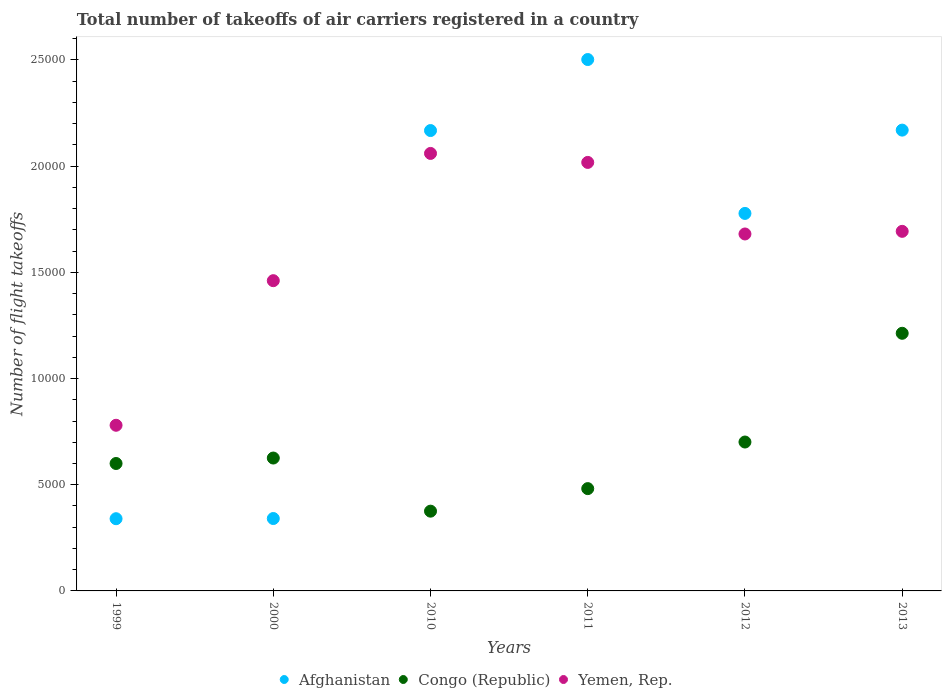How many different coloured dotlines are there?
Your response must be concise. 3. Is the number of dotlines equal to the number of legend labels?
Your answer should be very brief. Yes. What is the total number of flight takeoffs in Congo (Republic) in 2012?
Keep it short and to the point. 7011. Across all years, what is the maximum total number of flight takeoffs in Afghanistan?
Ensure brevity in your answer.  2.50e+04. Across all years, what is the minimum total number of flight takeoffs in Yemen, Rep.?
Ensure brevity in your answer.  7800. What is the total total number of flight takeoffs in Yemen, Rep. in the graph?
Provide a succinct answer. 9.69e+04. What is the difference between the total number of flight takeoffs in Afghanistan in 2012 and the total number of flight takeoffs in Congo (Republic) in 2010?
Offer a very short reply. 1.40e+04. What is the average total number of flight takeoffs in Congo (Republic) per year?
Provide a short and direct response. 6661.84. In the year 2000, what is the difference between the total number of flight takeoffs in Congo (Republic) and total number of flight takeoffs in Yemen, Rep.?
Provide a short and direct response. -8351. What is the ratio of the total number of flight takeoffs in Yemen, Rep. in 2010 to that in 2013?
Provide a short and direct response. 1.22. Is the total number of flight takeoffs in Yemen, Rep. in 1999 less than that in 2010?
Your response must be concise. Yes. Is the difference between the total number of flight takeoffs in Congo (Republic) in 2010 and 2011 greater than the difference between the total number of flight takeoffs in Yemen, Rep. in 2010 and 2011?
Your answer should be very brief. No. What is the difference between the highest and the second highest total number of flight takeoffs in Afghanistan?
Give a very brief answer. 3323.69. What is the difference between the highest and the lowest total number of flight takeoffs in Congo (Republic)?
Your response must be concise. 8375.4. In how many years, is the total number of flight takeoffs in Yemen, Rep. greater than the average total number of flight takeoffs in Yemen, Rep. taken over all years?
Make the answer very short. 4. Is the sum of the total number of flight takeoffs in Congo (Republic) in 2000 and 2011 greater than the maximum total number of flight takeoffs in Yemen, Rep. across all years?
Offer a very short reply. No. How many years are there in the graph?
Your answer should be very brief. 6. Are the values on the major ticks of Y-axis written in scientific E-notation?
Keep it short and to the point. No. Does the graph contain any zero values?
Give a very brief answer. No. Does the graph contain grids?
Ensure brevity in your answer.  No. Where does the legend appear in the graph?
Offer a terse response. Bottom center. How are the legend labels stacked?
Keep it short and to the point. Horizontal. What is the title of the graph?
Your answer should be compact. Total number of takeoffs of air carriers registered in a country. What is the label or title of the X-axis?
Give a very brief answer. Years. What is the label or title of the Y-axis?
Your response must be concise. Number of flight takeoffs. What is the Number of flight takeoffs in Afghanistan in 1999?
Offer a very short reply. 3400. What is the Number of flight takeoffs of Congo (Republic) in 1999?
Keep it short and to the point. 6000. What is the Number of flight takeoffs of Yemen, Rep. in 1999?
Make the answer very short. 7800. What is the Number of flight takeoffs in Afghanistan in 2000?
Ensure brevity in your answer.  3409. What is the Number of flight takeoffs in Congo (Republic) in 2000?
Offer a terse response. 6257. What is the Number of flight takeoffs in Yemen, Rep. in 2000?
Ensure brevity in your answer.  1.46e+04. What is the Number of flight takeoffs of Afghanistan in 2010?
Your answer should be compact. 2.17e+04. What is the Number of flight takeoffs of Congo (Republic) in 2010?
Offer a terse response. 3755.33. What is the Number of flight takeoffs in Yemen, Rep. in 2010?
Keep it short and to the point. 2.06e+04. What is the Number of flight takeoffs of Afghanistan in 2011?
Ensure brevity in your answer.  2.50e+04. What is the Number of flight takeoffs in Congo (Republic) in 2011?
Your answer should be very brief. 4817. What is the Number of flight takeoffs in Yemen, Rep. in 2011?
Your answer should be compact. 2.02e+04. What is the Number of flight takeoffs in Afghanistan in 2012?
Ensure brevity in your answer.  1.78e+04. What is the Number of flight takeoffs in Congo (Republic) in 2012?
Provide a succinct answer. 7011. What is the Number of flight takeoffs in Yemen, Rep. in 2012?
Provide a succinct answer. 1.68e+04. What is the Number of flight takeoffs of Afghanistan in 2013?
Your answer should be compact. 2.17e+04. What is the Number of flight takeoffs in Congo (Republic) in 2013?
Offer a very short reply. 1.21e+04. What is the Number of flight takeoffs of Yemen, Rep. in 2013?
Provide a short and direct response. 1.69e+04. Across all years, what is the maximum Number of flight takeoffs in Afghanistan?
Offer a terse response. 2.50e+04. Across all years, what is the maximum Number of flight takeoffs of Congo (Republic)?
Provide a short and direct response. 1.21e+04. Across all years, what is the maximum Number of flight takeoffs of Yemen, Rep.?
Keep it short and to the point. 2.06e+04. Across all years, what is the minimum Number of flight takeoffs of Afghanistan?
Your answer should be very brief. 3400. Across all years, what is the minimum Number of flight takeoffs in Congo (Republic)?
Your answer should be compact. 3755.33. Across all years, what is the minimum Number of flight takeoffs in Yemen, Rep.?
Your answer should be very brief. 7800. What is the total Number of flight takeoffs of Afghanistan in the graph?
Your response must be concise. 9.30e+04. What is the total Number of flight takeoffs of Congo (Republic) in the graph?
Make the answer very short. 4.00e+04. What is the total Number of flight takeoffs in Yemen, Rep. in the graph?
Ensure brevity in your answer.  9.69e+04. What is the difference between the Number of flight takeoffs in Congo (Republic) in 1999 and that in 2000?
Offer a terse response. -257. What is the difference between the Number of flight takeoffs of Yemen, Rep. in 1999 and that in 2000?
Ensure brevity in your answer.  -6808. What is the difference between the Number of flight takeoffs of Afghanistan in 1999 and that in 2010?
Give a very brief answer. -1.83e+04. What is the difference between the Number of flight takeoffs in Congo (Republic) in 1999 and that in 2010?
Provide a short and direct response. 2244.67. What is the difference between the Number of flight takeoffs of Yemen, Rep. in 1999 and that in 2010?
Keep it short and to the point. -1.28e+04. What is the difference between the Number of flight takeoffs in Afghanistan in 1999 and that in 2011?
Provide a succinct answer. -2.16e+04. What is the difference between the Number of flight takeoffs of Congo (Republic) in 1999 and that in 2011?
Offer a very short reply. 1183. What is the difference between the Number of flight takeoffs of Yemen, Rep. in 1999 and that in 2011?
Offer a terse response. -1.24e+04. What is the difference between the Number of flight takeoffs in Afghanistan in 1999 and that in 2012?
Offer a very short reply. -1.44e+04. What is the difference between the Number of flight takeoffs of Congo (Republic) in 1999 and that in 2012?
Provide a short and direct response. -1011. What is the difference between the Number of flight takeoffs in Yemen, Rep. in 1999 and that in 2012?
Offer a very short reply. -9007.41. What is the difference between the Number of flight takeoffs of Afghanistan in 1999 and that in 2013?
Ensure brevity in your answer.  -1.83e+04. What is the difference between the Number of flight takeoffs of Congo (Republic) in 1999 and that in 2013?
Offer a very short reply. -6130.73. What is the difference between the Number of flight takeoffs in Yemen, Rep. in 1999 and that in 2013?
Provide a short and direct response. -9131.24. What is the difference between the Number of flight takeoffs of Afghanistan in 2000 and that in 2010?
Keep it short and to the point. -1.83e+04. What is the difference between the Number of flight takeoffs in Congo (Republic) in 2000 and that in 2010?
Provide a short and direct response. 2501.67. What is the difference between the Number of flight takeoffs of Yemen, Rep. in 2000 and that in 2010?
Your answer should be compact. -5992. What is the difference between the Number of flight takeoffs in Afghanistan in 2000 and that in 2011?
Offer a terse response. -2.16e+04. What is the difference between the Number of flight takeoffs of Congo (Republic) in 2000 and that in 2011?
Provide a succinct answer. 1440. What is the difference between the Number of flight takeoffs of Yemen, Rep. in 2000 and that in 2011?
Keep it short and to the point. -5568.73. What is the difference between the Number of flight takeoffs in Afghanistan in 2000 and that in 2012?
Your answer should be very brief. -1.44e+04. What is the difference between the Number of flight takeoffs of Congo (Republic) in 2000 and that in 2012?
Your response must be concise. -754. What is the difference between the Number of flight takeoffs in Yemen, Rep. in 2000 and that in 2012?
Your answer should be very brief. -2199.41. What is the difference between the Number of flight takeoffs of Afghanistan in 2000 and that in 2013?
Provide a succinct answer. -1.83e+04. What is the difference between the Number of flight takeoffs of Congo (Republic) in 2000 and that in 2013?
Your answer should be compact. -5873.73. What is the difference between the Number of flight takeoffs in Yemen, Rep. in 2000 and that in 2013?
Give a very brief answer. -2323.24. What is the difference between the Number of flight takeoffs of Afghanistan in 2010 and that in 2011?
Give a very brief answer. -3344. What is the difference between the Number of flight takeoffs in Congo (Republic) in 2010 and that in 2011?
Offer a terse response. -1061.67. What is the difference between the Number of flight takeoffs in Yemen, Rep. in 2010 and that in 2011?
Offer a terse response. 423.27. What is the difference between the Number of flight takeoffs of Afghanistan in 2010 and that in 2012?
Your answer should be very brief. 3902. What is the difference between the Number of flight takeoffs in Congo (Republic) in 2010 and that in 2012?
Provide a short and direct response. -3255.67. What is the difference between the Number of flight takeoffs in Yemen, Rep. in 2010 and that in 2012?
Give a very brief answer. 3792.59. What is the difference between the Number of flight takeoffs in Afghanistan in 2010 and that in 2013?
Provide a short and direct response. -20.31. What is the difference between the Number of flight takeoffs in Congo (Republic) in 2010 and that in 2013?
Offer a terse response. -8375.4. What is the difference between the Number of flight takeoffs of Yemen, Rep. in 2010 and that in 2013?
Give a very brief answer. 3668.76. What is the difference between the Number of flight takeoffs in Afghanistan in 2011 and that in 2012?
Your answer should be very brief. 7246. What is the difference between the Number of flight takeoffs in Congo (Republic) in 2011 and that in 2012?
Your answer should be compact. -2194. What is the difference between the Number of flight takeoffs in Yemen, Rep. in 2011 and that in 2012?
Ensure brevity in your answer.  3369.32. What is the difference between the Number of flight takeoffs of Afghanistan in 2011 and that in 2013?
Make the answer very short. 3323.69. What is the difference between the Number of flight takeoffs in Congo (Republic) in 2011 and that in 2013?
Offer a terse response. -7313.73. What is the difference between the Number of flight takeoffs in Yemen, Rep. in 2011 and that in 2013?
Provide a short and direct response. 3245.49. What is the difference between the Number of flight takeoffs of Afghanistan in 2012 and that in 2013?
Your answer should be compact. -3922.31. What is the difference between the Number of flight takeoffs of Congo (Republic) in 2012 and that in 2013?
Provide a succinct answer. -5119.73. What is the difference between the Number of flight takeoffs in Yemen, Rep. in 2012 and that in 2013?
Provide a succinct answer. -123.83. What is the difference between the Number of flight takeoffs of Afghanistan in 1999 and the Number of flight takeoffs of Congo (Republic) in 2000?
Provide a short and direct response. -2857. What is the difference between the Number of flight takeoffs in Afghanistan in 1999 and the Number of flight takeoffs in Yemen, Rep. in 2000?
Make the answer very short. -1.12e+04. What is the difference between the Number of flight takeoffs of Congo (Republic) in 1999 and the Number of flight takeoffs of Yemen, Rep. in 2000?
Your response must be concise. -8608. What is the difference between the Number of flight takeoffs in Afghanistan in 1999 and the Number of flight takeoffs in Congo (Republic) in 2010?
Offer a very short reply. -355.33. What is the difference between the Number of flight takeoffs of Afghanistan in 1999 and the Number of flight takeoffs of Yemen, Rep. in 2010?
Offer a terse response. -1.72e+04. What is the difference between the Number of flight takeoffs of Congo (Republic) in 1999 and the Number of flight takeoffs of Yemen, Rep. in 2010?
Give a very brief answer. -1.46e+04. What is the difference between the Number of flight takeoffs of Afghanistan in 1999 and the Number of flight takeoffs of Congo (Republic) in 2011?
Make the answer very short. -1417. What is the difference between the Number of flight takeoffs of Afghanistan in 1999 and the Number of flight takeoffs of Yemen, Rep. in 2011?
Your answer should be compact. -1.68e+04. What is the difference between the Number of flight takeoffs of Congo (Republic) in 1999 and the Number of flight takeoffs of Yemen, Rep. in 2011?
Provide a succinct answer. -1.42e+04. What is the difference between the Number of flight takeoffs in Afghanistan in 1999 and the Number of flight takeoffs in Congo (Republic) in 2012?
Your answer should be compact. -3611. What is the difference between the Number of flight takeoffs in Afghanistan in 1999 and the Number of flight takeoffs in Yemen, Rep. in 2012?
Your answer should be very brief. -1.34e+04. What is the difference between the Number of flight takeoffs in Congo (Republic) in 1999 and the Number of flight takeoffs in Yemen, Rep. in 2012?
Your answer should be compact. -1.08e+04. What is the difference between the Number of flight takeoffs of Afghanistan in 1999 and the Number of flight takeoffs of Congo (Republic) in 2013?
Provide a succinct answer. -8730.73. What is the difference between the Number of flight takeoffs in Afghanistan in 1999 and the Number of flight takeoffs in Yemen, Rep. in 2013?
Your answer should be compact. -1.35e+04. What is the difference between the Number of flight takeoffs of Congo (Republic) in 1999 and the Number of flight takeoffs of Yemen, Rep. in 2013?
Keep it short and to the point. -1.09e+04. What is the difference between the Number of flight takeoffs of Afghanistan in 2000 and the Number of flight takeoffs of Congo (Republic) in 2010?
Keep it short and to the point. -346.33. What is the difference between the Number of flight takeoffs in Afghanistan in 2000 and the Number of flight takeoffs in Yemen, Rep. in 2010?
Make the answer very short. -1.72e+04. What is the difference between the Number of flight takeoffs in Congo (Republic) in 2000 and the Number of flight takeoffs in Yemen, Rep. in 2010?
Your answer should be compact. -1.43e+04. What is the difference between the Number of flight takeoffs of Afghanistan in 2000 and the Number of flight takeoffs of Congo (Republic) in 2011?
Offer a very short reply. -1408. What is the difference between the Number of flight takeoffs of Afghanistan in 2000 and the Number of flight takeoffs of Yemen, Rep. in 2011?
Your response must be concise. -1.68e+04. What is the difference between the Number of flight takeoffs in Congo (Republic) in 2000 and the Number of flight takeoffs in Yemen, Rep. in 2011?
Ensure brevity in your answer.  -1.39e+04. What is the difference between the Number of flight takeoffs in Afghanistan in 2000 and the Number of flight takeoffs in Congo (Republic) in 2012?
Your response must be concise. -3602. What is the difference between the Number of flight takeoffs of Afghanistan in 2000 and the Number of flight takeoffs of Yemen, Rep. in 2012?
Make the answer very short. -1.34e+04. What is the difference between the Number of flight takeoffs of Congo (Republic) in 2000 and the Number of flight takeoffs of Yemen, Rep. in 2012?
Your answer should be very brief. -1.06e+04. What is the difference between the Number of flight takeoffs of Afghanistan in 2000 and the Number of flight takeoffs of Congo (Republic) in 2013?
Provide a succinct answer. -8721.73. What is the difference between the Number of flight takeoffs in Afghanistan in 2000 and the Number of flight takeoffs in Yemen, Rep. in 2013?
Offer a terse response. -1.35e+04. What is the difference between the Number of flight takeoffs in Congo (Republic) in 2000 and the Number of flight takeoffs in Yemen, Rep. in 2013?
Provide a short and direct response. -1.07e+04. What is the difference between the Number of flight takeoffs of Afghanistan in 2010 and the Number of flight takeoffs of Congo (Republic) in 2011?
Your response must be concise. 1.69e+04. What is the difference between the Number of flight takeoffs in Afghanistan in 2010 and the Number of flight takeoffs in Yemen, Rep. in 2011?
Ensure brevity in your answer.  1500.27. What is the difference between the Number of flight takeoffs in Congo (Republic) in 2010 and the Number of flight takeoffs in Yemen, Rep. in 2011?
Your response must be concise. -1.64e+04. What is the difference between the Number of flight takeoffs of Afghanistan in 2010 and the Number of flight takeoffs of Congo (Republic) in 2012?
Provide a short and direct response. 1.47e+04. What is the difference between the Number of flight takeoffs of Afghanistan in 2010 and the Number of flight takeoffs of Yemen, Rep. in 2012?
Keep it short and to the point. 4869.59. What is the difference between the Number of flight takeoffs of Congo (Republic) in 2010 and the Number of flight takeoffs of Yemen, Rep. in 2012?
Your answer should be very brief. -1.31e+04. What is the difference between the Number of flight takeoffs in Afghanistan in 2010 and the Number of flight takeoffs in Congo (Republic) in 2013?
Make the answer very short. 9546.27. What is the difference between the Number of flight takeoffs of Afghanistan in 2010 and the Number of flight takeoffs of Yemen, Rep. in 2013?
Your answer should be very brief. 4745.76. What is the difference between the Number of flight takeoffs of Congo (Republic) in 2010 and the Number of flight takeoffs of Yemen, Rep. in 2013?
Provide a short and direct response. -1.32e+04. What is the difference between the Number of flight takeoffs of Afghanistan in 2011 and the Number of flight takeoffs of Congo (Republic) in 2012?
Give a very brief answer. 1.80e+04. What is the difference between the Number of flight takeoffs of Afghanistan in 2011 and the Number of flight takeoffs of Yemen, Rep. in 2012?
Offer a very short reply. 8213.59. What is the difference between the Number of flight takeoffs of Congo (Republic) in 2011 and the Number of flight takeoffs of Yemen, Rep. in 2012?
Your answer should be compact. -1.20e+04. What is the difference between the Number of flight takeoffs in Afghanistan in 2011 and the Number of flight takeoffs in Congo (Republic) in 2013?
Your response must be concise. 1.29e+04. What is the difference between the Number of flight takeoffs in Afghanistan in 2011 and the Number of flight takeoffs in Yemen, Rep. in 2013?
Your answer should be compact. 8089.76. What is the difference between the Number of flight takeoffs in Congo (Republic) in 2011 and the Number of flight takeoffs in Yemen, Rep. in 2013?
Provide a succinct answer. -1.21e+04. What is the difference between the Number of flight takeoffs of Afghanistan in 2012 and the Number of flight takeoffs of Congo (Republic) in 2013?
Your answer should be compact. 5644.27. What is the difference between the Number of flight takeoffs of Afghanistan in 2012 and the Number of flight takeoffs of Yemen, Rep. in 2013?
Make the answer very short. 843.76. What is the difference between the Number of flight takeoffs of Congo (Republic) in 2012 and the Number of flight takeoffs of Yemen, Rep. in 2013?
Your response must be concise. -9920.24. What is the average Number of flight takeoffs of Afghanistan per year?
Your response must be concise. 1.55e+04. What is the average Number of flight takeoffs in Congo (Republic) per year?
Offer a terse response. 6661.84. What is the average Number of flight takeoffs of Yemen, Rep. per year?
Offer a terse response. 1.62e+04. In the year 1999, what is the difference between the Number of flight takeoffs in Afghanistan and Number of flight takeoffs in Congo (Republic)?
Keep it short and to the point. -2600. In the year 1999, what is the difference between the Number of flight takeoffs of Afghanistan and Number of flight takeoffs of Yemen, Rep.?
Your answer should be compact. -4400. In the year 1999, what is the difference between the Number of flight takeoffs of Congo (Republic) and Number of flight takeoffs of Yemen, Rep.?
Offer a very short reply. -1800. In the year 2000, what is the difference between the Number of flight takeoffs in Afghanistan and Number of flight takeoffs in Congo (Republic)?
Your answer should be compact. -2848. In the year 2000, what is the difference between the Number of flight takeoffs in Afghanistan and Number of flight takeoffs in Yemen, Rep.?
Your response must be concise. -1.12e+04. In the year 2000, what is the difference between the Number of flight takeoffs of Congo (Republic) and Number of flight takeoffs of Yemen, Rep.?
Your answer should be compact. -8351. In the year 2010, what is the difference between the Number of flight takeoffs in Afghanistan and Number of flight takeoffs in Congo (Republic)?
Give a very brief answer. 1.79e+04. In the year 2010, what is the difference between the Number of flight takeoffs of Afghanistan and Number of flight takeoffs of Yemen, Rep.?
Provide a succinct answer. 1077. In the year 2010, what is the difference between the Number of flight takeoffs of Congo (Republic) and Number of flight takeoffs of Yemen, Rep.?
Your answer should be very brief. -1.68e+04. In the year 2011, what is the difference between the Number of flight takeoffs in Afghanistan and Number of flight takeoffs in Congo (Republic)?
Provide a short and direct response. 2.02e+04. In the year 2011, what is the difference between the Number of flight takeoffs in Afghanistan and Number of flight takeoffs in Yemen, Rep.?
Your answer should be very brief. 4844.27. In the year 2011, what is the difference between the Number of flight takeoffs in Congo (Republic) and Number of flight takeoffs in Yemen, Rep.?
Ensure brevity in your answer.  -1.54e+04. In the year 2012, what is the difference between the Number of flight takeoffs in Afghanistan and Number of flight takeoffs in Congo (Republic)?
Give a very brief answer. 1.08e+04. In the year 2012, what is the difference between the Number of flight takeoffs in Afghanistan and Number of flight takeoffs in Yemen, Rep.?
Offer a very short reply. 967.59. In the year 2012, what is the difference between the Number of flight takeoffs of Congo (Republic) and Number of flight takeoffs of Yemen, Rep.?
Provide a short and direct response. -9796.41. In the year 2013, what is the difference between the Number of flight takeoffs of Afghanistan and Number of flight takeoffs of Congo (Republic)?
Ensure brevity in your answer.  9566.57. In the year 2013, what is the difference between the Number of flight takeoffs of Afghanistan and Number of flight takeoffs of Yemen, Rep.?
Your response must be concise. 4766.07. In the year 2013, what is the difference between the Number of flight takeoffs in Congo (Republic) and Number of flight takeoffs in Yemen, Rep.?
Make the answer very short. -4800.51. What is the ratio of the Number of flight takeoffs of Afghanistan in 1999 to that in 2000?
Your answer should be very brief. 1. What is the ratio of the Number of flight takeoffs in Congo (Republic) in 1999 to that in 2000?
Your answer should be compact. 0.96. What is the ratio of the Number of flight takeoffs in Yemen, Rep. in 1999 to that in 2000?
Your answer should be compact. 0.53. What is the ratio of the Number of flight takeoffs of Afghanistan in 1999 to that in 2010?
Your answer should be compact. 0.16. What is the ratio of the Number of flight takeoffs in Congo (Republic) in 1999 to that in 2010?
Offer a terse response. 1.6. What is the ratio of the Number of flight takeoffs in Yemen, Rep. in 1999 to that in 2010?
Your answer should be compact. 0.38. What is the ratio of the Number of flight takeoffs of Afghanistan in 1999 to that in 2011?
Ensure brevity in your answer.  0.14. What is the ratio of the Number of flight takeoffs of Congo (Republic) in 1999 to that in 2011?
Keep it short and to the point. 1.25. What is the ratio of the Number of flight takeoffs of Yemen, Rep. in 1999 to that in 2011?
Your answer should be compact. 0.39. What is the ratio of the Number of flight takeoffs of Afghanistan in 1999 to that in 2012?
Keep it short and to the point. 0.19. What is the ratio of the Number of flight takeoffs in Congo (Republic) in 1999 to that in 2012?
Make the answer very short. 0.86. What is the ratio of the Number of flight takeoffs in Yemen, Rep. in 1999 to that in 2012?
Provide a short and direct response. 0.46. What is the ratio of the Number of flight takeoffs in Afghanistan in 1999 to that in 2013?
Keep it short and to the point. 0.16. What is the ratio of the Number of flight takeoffs in Congo (Republic) in 1999 to that in 2013?
Your response must be concise. 0.49. What is the ratio of the Number of flight takeoffs of Yemen, Rep. in 1999 to that in 2013?
Make the answer very short. 0.46. What is the ratio of the Number of flight takeoffs in Afghanistan in 2000 to that in 2010?
Your answer should be very brief. 0.16. What is the ratio of the Number of flight takeoffs in Congo (Republic) in 2000 to that in 2010?
Make the answer very short. 1.67. What is the ratio of the Number of flight takeoffs of Yemen, Rep. in 2000 to that in 2010?
Offer a terse response. 0.71. What is the ratio of the Number of flight takeoffs of Afghanistan in 2000 to that in 2011?
Give a very brief answer. 0.14. What is the ratio of the Number of flight takeoffs in Congo (Republic) in 2000 to that in 2011?
Your answer should be very brief. 1.3. What is the ratio of the Number of flight takeoffs of Yemen, Rep. in 2000 to that in 2011?
Ensure brevity in your answer.  0.72. What is the ratio of the Number of flight takeoffs of Afghanistan in 2000 to that in 2012?
Your answer should be compact. 0.19. What is the ratio of the Number of flight takeoffs of Congo (Republic) in 2000 to that in 2012?
Keep it short and to the point. 0.89. What is the ratio of the Number of flight takeoffs of Yemen, Rep. in 2000 to that in 2012?
Ensure brevity in your answer.  0.87. What is the ratio of the Number of flight takeoffs of Afghanistan in 2000 to that in 2013?
Your answer should be compact. 0.16. What is the ratio of the Number of flight takeoffs of Congo (Republic) in 2000 to that in 2013?
Provide a short and direct response. 0.52. What is the ratio of the Number of flight takeoffs in Yemen, Rep. in 2000 to that in 2013?
Offer a terse response. 0.86. What is the ratio of the Number of flight takeoffs of Afghanistan in 2010 to that in 2011?
Your answer should be compact. 0.87. What is the ratio of the Number of flight takeoffs of Congo (Republic) in 2010 to that in 2011?
Your answer should be compact. 0.78. What is the ratio of the Number of flight takeoffs of Yemen, Rep. in 2010 to that in 2011?
Ensure brevity in your answer.  1.02. What is the ratio of the Number of flight takeoffs of Afghanistan in 2010 to that in 2012?
Your answer should be very brief. 1.22. What is the ratio of the Number of flight takeoffs of Congo (Republic) in 2010 to that in 2012?
Offer a very short reply. 0.54. What is the ratio of the Number of flight takeoffs in Yemen, Rep. in 2010 to that in 2012?
Offer a very short reply. 1.23. What is the ratio of the Number of flight takeoffs in Congo (Republic) in 2010 to that in 2013?
Provide a succinct answer. 0.31. What is the ratio of the Number of flight takeoffs of Yemen, Rep. in 2010 to that in 2013?
Make the answer very short. 1.22. What is the ratio of the Number of flight takeoffs of Afghanistan in 2011 to that in 2012?
Ensure brevity in your answer.  1.41. What is the ratio of the Number of flight takeoffs in Congo (Republic) in 2011 to that in 2012?
Make the answer very short. 0.69. What is the ratio of the Number of flight takeoffs of Yemen, Rep. in 2011 to that in 2012?
Your response must be concise. 1.2. What is the ratio of the Number of flight takeoffs in Afghanistan in 2011 to that in 2013?
Provide a short and direct response. 1.15. What is the ratio of the Number of flight takeoffs in Congo (Republic) in 2011 to that in 2013?
Your response must be concise. 0.4. What is the ratio of the Number of flight takeoffs of Yemen, Rep. in 2011 to that in 2013?
Offer a terse response. 1.19. What is the ratio of the Number of flight takeoffs in Afghanistan in 2012 to that in 2013?
Your response must be concise. 0.82. What is the ratio of the Number of flight takeoffs in Congo (Republic) in 2012 to that in 2013?
Provide a short and direct response. 0.58. What is the difference between the highest and the second highest Number of flight takeoffs of Afghanistan?
Give a very brief answer. 3323.69. What is the difference between the highest and the second highest Number of flight takeoffs of Congo (Republic)?
Your response must be concise. 5119.73. What is the difference between the highest and the second highest Number of flight takeoffs in Yemen, Rep.?
Offer a terse response. 423.27. What is the difference between the highest and the lowest Number of flight takeoffs in Afghanistan?
Offer a terse response. 2.16e+04. What is the difference between the highest and the lowest Number of flight takeoffs in Congo (Republic)?
Your response must be concise. 8375.4. What is the difference between the highest and the lowest Number of flight takeoffs of Yemen, Rep.?
Keep it short and to the point. 1.28e+04. 